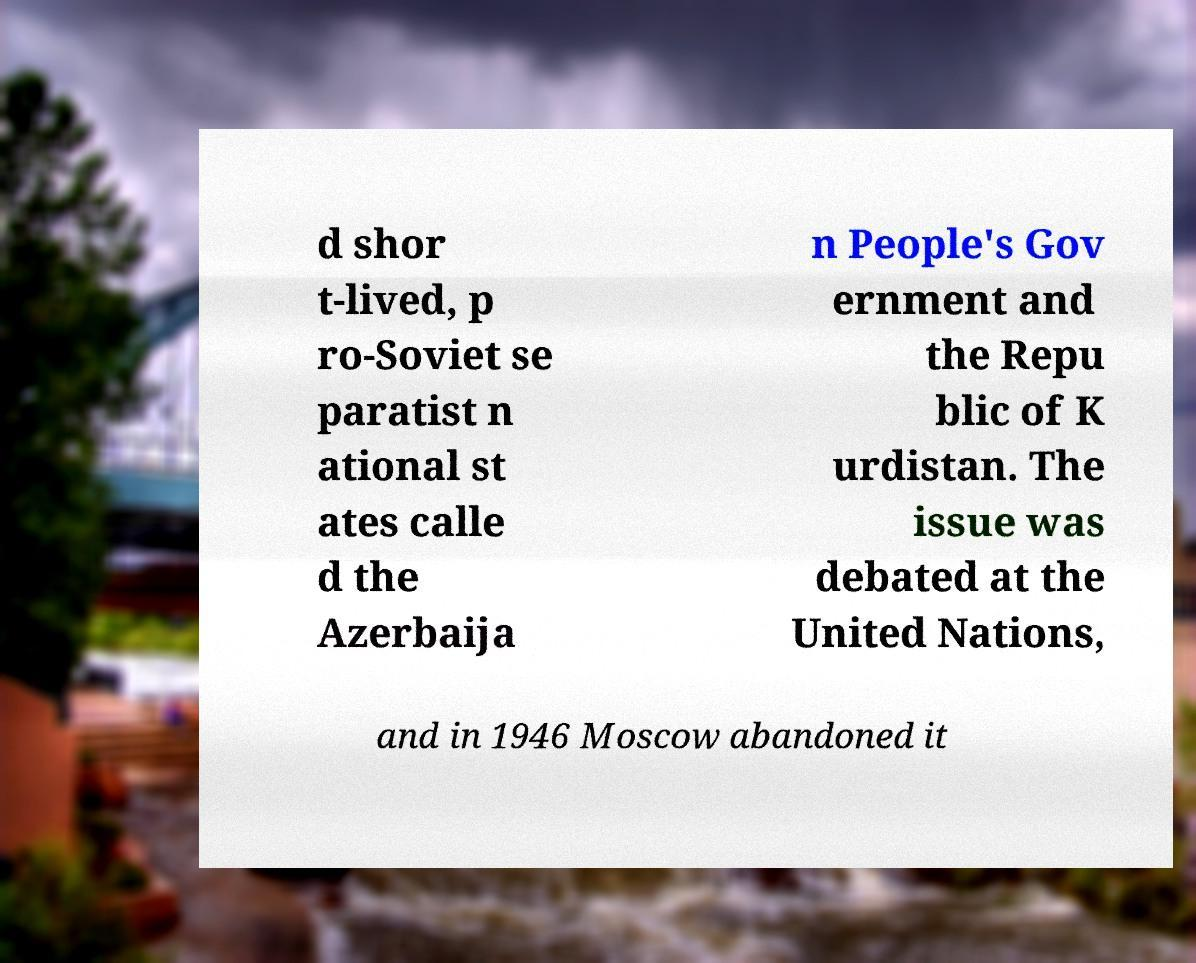Can you read and provide the text displayed in the image?This photo seems to have some interesting text. Can you extract and type it out for me? d shor t-lived, p ro-Soviet se paratist n ational st ates calle d the Azerbaija n People's Gov ernment and the Repu blic of K urdistan. The issue was debated at the United Nations, and in 1946 Moscow abandoned it 